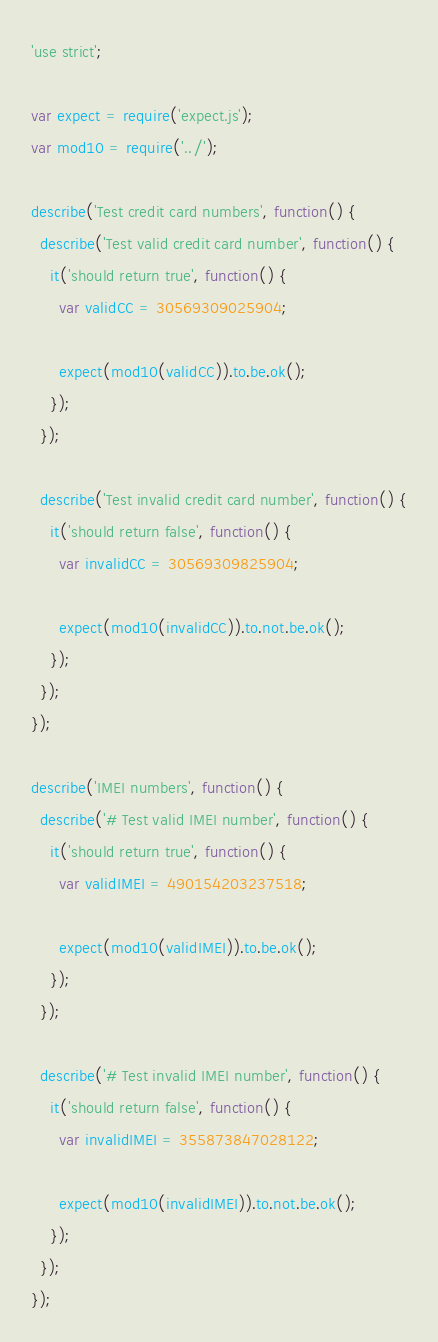Convert code to text. <code><loc_0><loc_0><loc_500><loc_500><_JavaScript_>'use strict';

var expect = require('expect.js');
var mod10 = require('../');

describe('Test credit card numbers', function() {
  describe('Test valid credit card number', function() {
    it('should return true', function() {
      var validCC = 30569309025904;

      expect(mod10(validCC)).to.be.ok();
    });
  });

  describe('Test invalid credit card number', function() {
    it('should return false', function() {
      var invalidCC = 30569309825904;

      expect(mod10(invalidCC)).to.not.be.ok();
    });
  });
});

describe('IMEI numbers', function() {
  describe('# Test valid IMEI number', function() {
    it('should return true', function() {
      var validIMEI = 490154203237518;

      expect(mod10(validIMEI)).to.be.ok();
    });
  });

  describe('# Test invalid IMEI number', function() {
    it('should return false', function() {
      var invalidIMEI = 355873847028122;

      expect(mod10(invalidIMEI)).to.not.be.ok();
    });
  });
});
</code> 